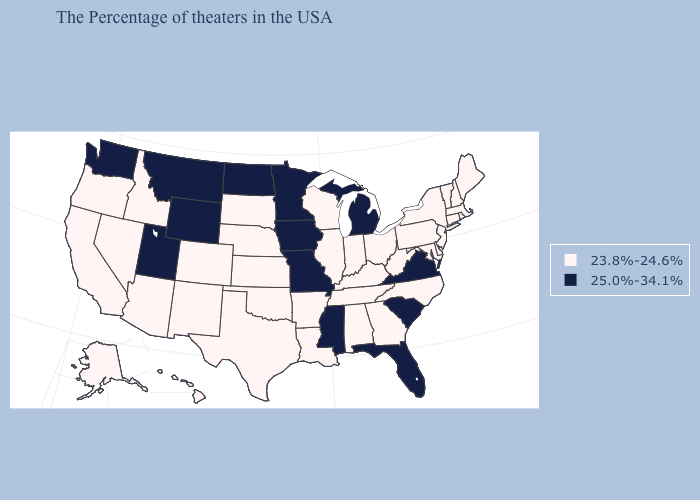Does Kentucky have the lowest value in the USA?
Quick response, please. Yes. Among the states that border Oklahoma , which have the lowest value?
Answer briefly. Arkansas, Kansas, Texas, Colorado, New Mexico. Name the states that have a value in the range 25.0%-34.1%?
Give a very brief answer. Virginia, South Carolina, Florida, Michigan, Mississippi, Missouri, Minnesota, Iowa, North Dakota, Wyoming, Utah, Montana, Washington. Name the states that have a value in the range 23.8%-24.6%?
Give a very brief answer. Maine, Massachusetts, Rhode Island, New Hampshire, Vermont, Connecticut, New York, New Jersey, Delaware, Maryland, Pennsylvania, North Carolina, West Virginia, Ohio, Georgia, Kentucky, Indiana, Alabama, Tennessee, Wisconsin, Illinois, Louisiana, Arkansas, Kansas, Nebraska, Oklahoma, Texas, South Dakota, Colorado, New Mexico, Arizona, Idaho, Nevada, California, Oregon, Alaska, Hawaii. What is the value of Mississippi?
Answer briefly. 25.0%-34.1%. Which states have the highest value in the USA?
Write a very short answer. Virginia, South Carolina, Florida, Michigan, Mississippi, Missouri, Minnesota, Iowa, North Dakota, Wyoming, Utah, Montana, Washington. Does Utah have the same value as New York?
Be succinct. No. Name the states that have a value in the range 23.8%-24.6%?
Keep it brief. Maine, Massachusetts, Rhode Island, New Hampshire, Vermont, Connecticut, New York, New Jersey, Delaware, Maryland, Pennsylvania, North Carolina, West Virginia, Ohio, Georgia, Kentucky, Indiana, Alabama, Tennessee, Wisconsin, Illinois, Louisiana, Arkansas, Kansas, Nebraska, Oklahoma, Texas, South Dakota, Colorado, New Mexico, Arizona, Idaho, Nevada, California, Oregon, Alaska, Hawaii. Which states hav the highest value in the West?
Be succinct. Wyoming, Utah, Montana, Washington. Name the states that have a value in the range 25.0%-34.1%?
Concise answer only. Virginia, South Carolina, Florida, Michigan, Mississippi, Missouri, Minnesota, Iowa, North Dakota, Wyoming, Utah, Montana, Washington. Does Wyoming have the highest value in the West?
Be succinct. Yes. Does Colorado have a lower value than Montana?
Keep it brief. Yes. Does Washington have the lowest value in the West?
Give a very brief answer. No. Name the states that have a value in the range 25.0%-34.1%?
Quick response, please. Virginia, South Carolina, Florida, Michigan, Mississippi, Missouri, Minnesota, Iowa, North Dakota, Wyoming, Utah, Montana, Washington. 